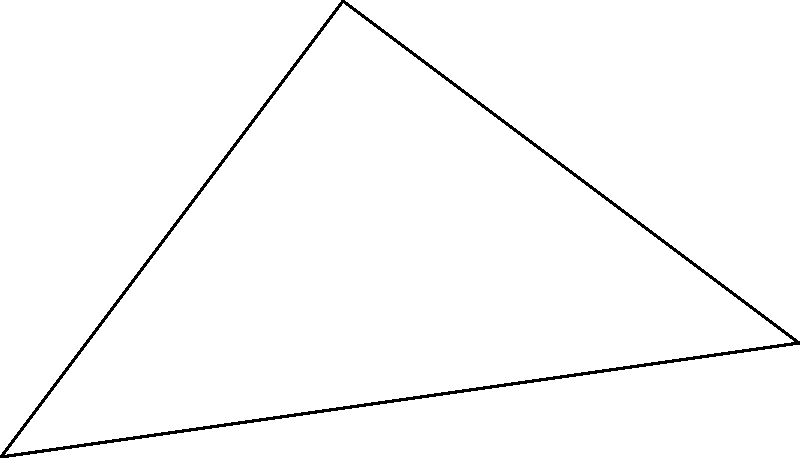As a car enthusiast helping beginners understand vehicle dynamics, you're explaining how to calculate a car's turning radius. Using the coordinate system shown, where O(0,0) is the center of the turning circle, A(3,4) is the front wheel position, and B(7,1) is the rear wheel position, what is the turning radius R of the car? Let's break this down into simple steps:

1) The turning radius R is the distance from the center O to either wheel position (A or B).

2) We can use the distance formula to calculate R:
   $$R = \sqrt{(x_A - x_O)^2 + (y_A - y_O)^2}$$

3) We know that O is at (0,0) and A is at (3,4). Let's plug these into our formula:
   $$R = \sqrt{(3 - 0)^2 + (4 - 0)^2}$$

4) Simplify:
   $$R = \sqrt{3^2 + 4^2}$$

5) Calculate:
   $$R = \sqrt{9 + 16} = \sqrt{25} = 5$$

So, the turning radius R is 5 units.

Fun fact for car enthusiasts: In real cars, a smaller turning radius means the car can make tighter turns, which is great for maneuvering in tight spaces!
Answer: 5 units 